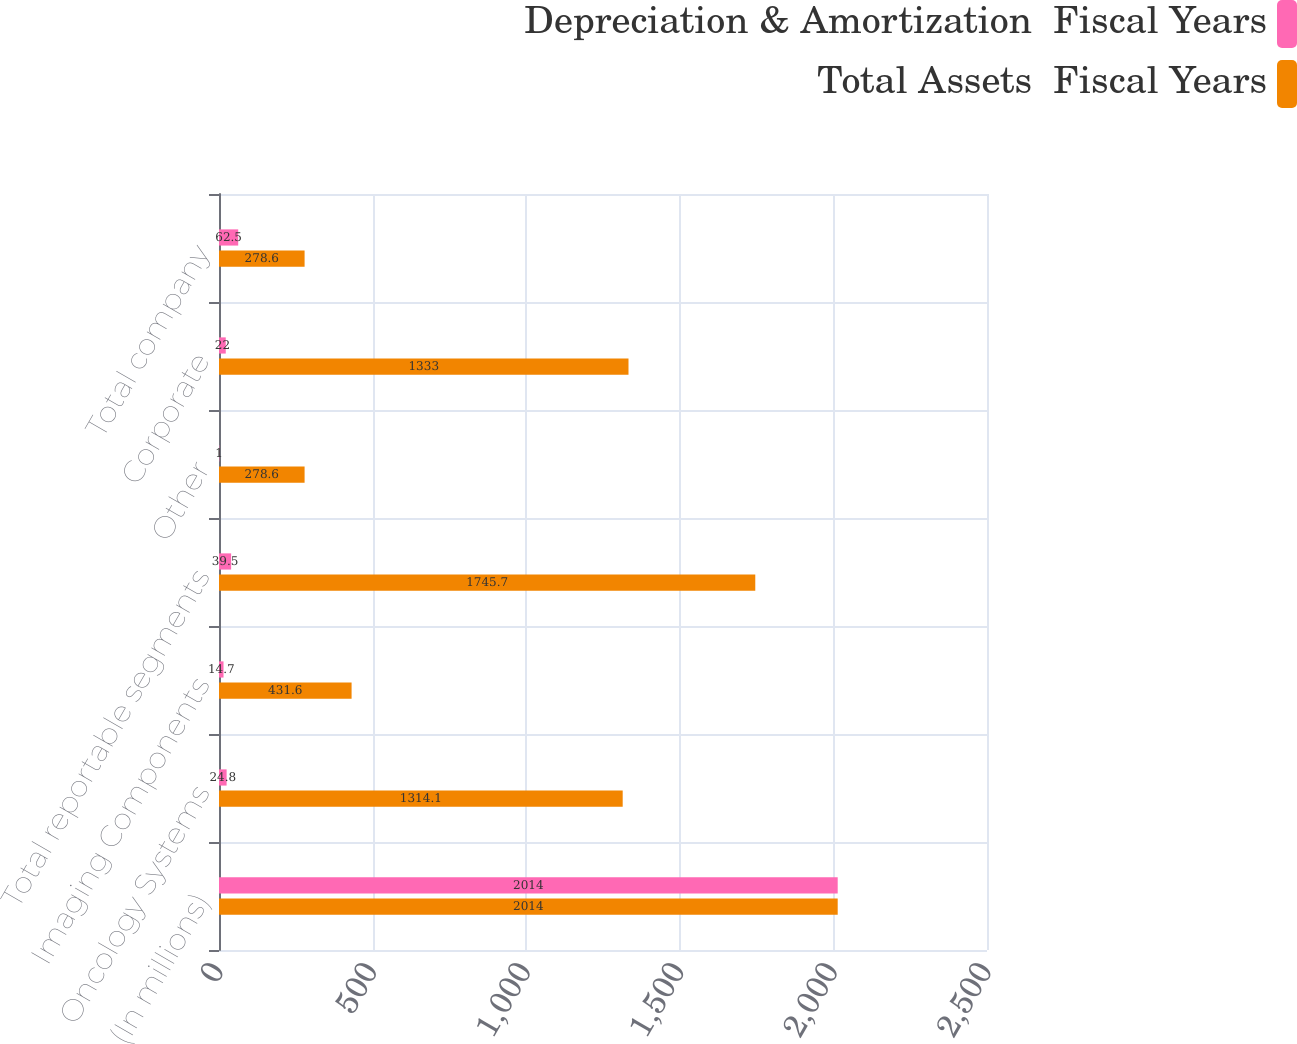Convert chart to OTSL. <chart><loc_0><loc_0><loc_500><loc_500><stacked_bar_chart><ecel><fcel>(In millions)<fcel>Oncology Systems<fcel>Imaging Components<fcel>Total reportable segments<fcel>Other<fcel>Corporate<fcel>Total company<nl><fcel>Depreciation & Amortization  Fiscal Years<fcel>2014<fcel>24.8<fcel>14.7<fcel>39.5<fcel>1<fcel>22<fcel>62.5<nl><fcel>Total Assets  Fiscal Years<fcel>2014<fcel>1314.1<fcel>431.6<fcel>1745.7<fcel>278.6<fcel>1333<fcel>278.6<nl></chart> 